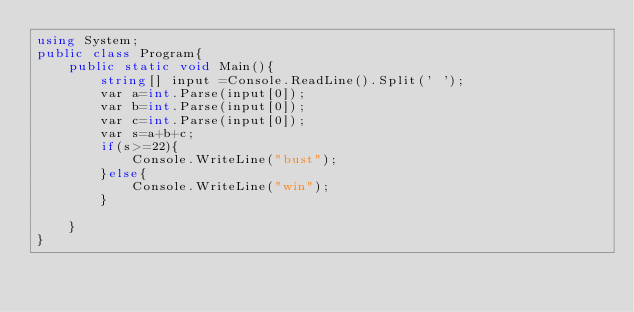<code> <loc_0><loc_0><loc_500><loc_500><_C#_>using System;
public class Program{
    public static void Main(){
        string[] input =Console.ReadLine().Split(' ');
        var a=int.Parse(input[0]);
        var b=int.Parse(input[0]);
        var c=int.Parse(input[0]);
        var s=a+b+c;
        if(s>=22){
            Console.WriteLine("bust");
        }else{
            Console.WriteLine("win");
        }
        
    }
}
</code> 